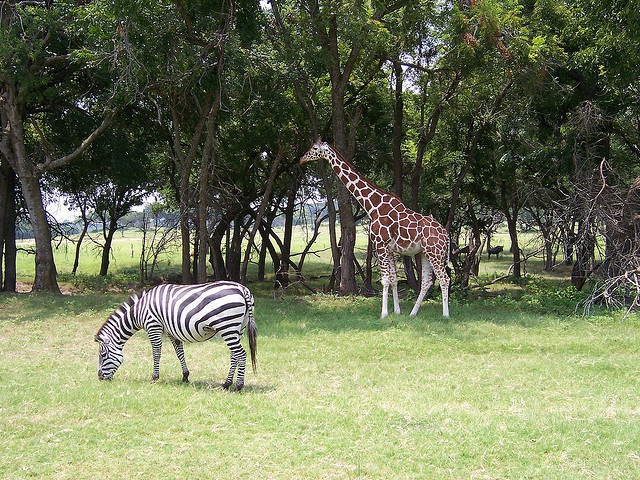Describe the objects in this image and their specific colors. I can see zebra in black, white, gray, and darkgray tones and giraffe in black, lightgray, maroon, darkgray, and gray tones in this image. 